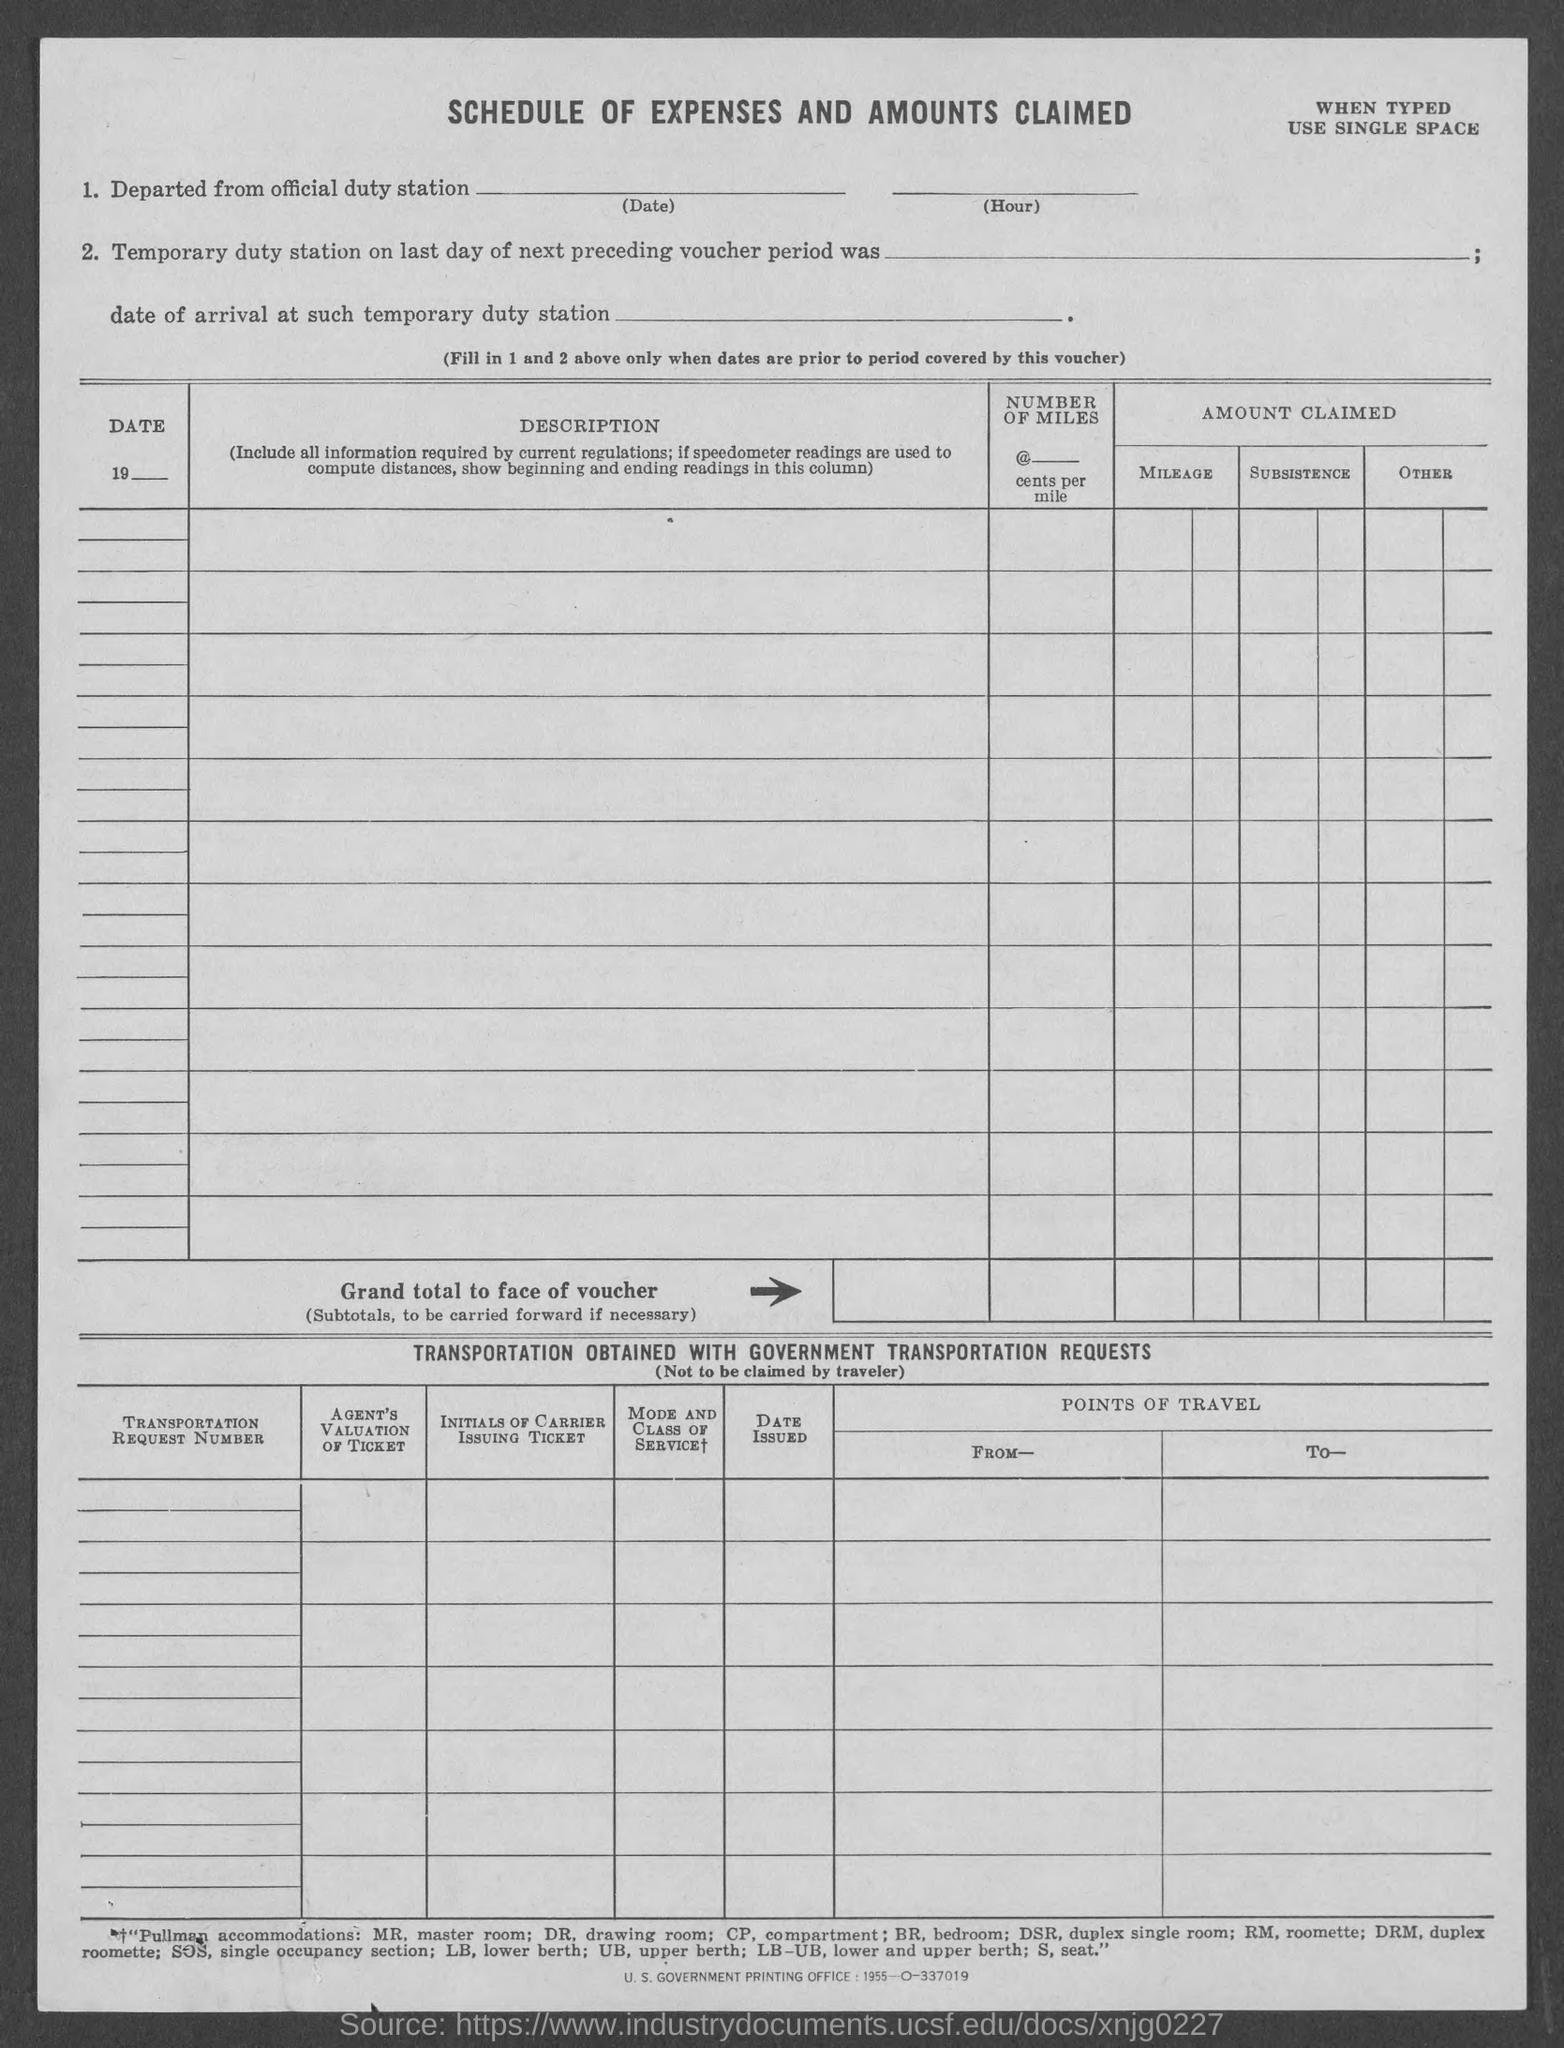Indicate a few pertinent items in this graphic. The second table is titled "Transportation Obtained with Government Transportation Requests. The term 'SOS' commonly refers to 'single occupancy section,' indicating that the designated area is reserved for single occupancy usage. The title of this document is 'Schedule of Expenses and Amounts Claimed.' 